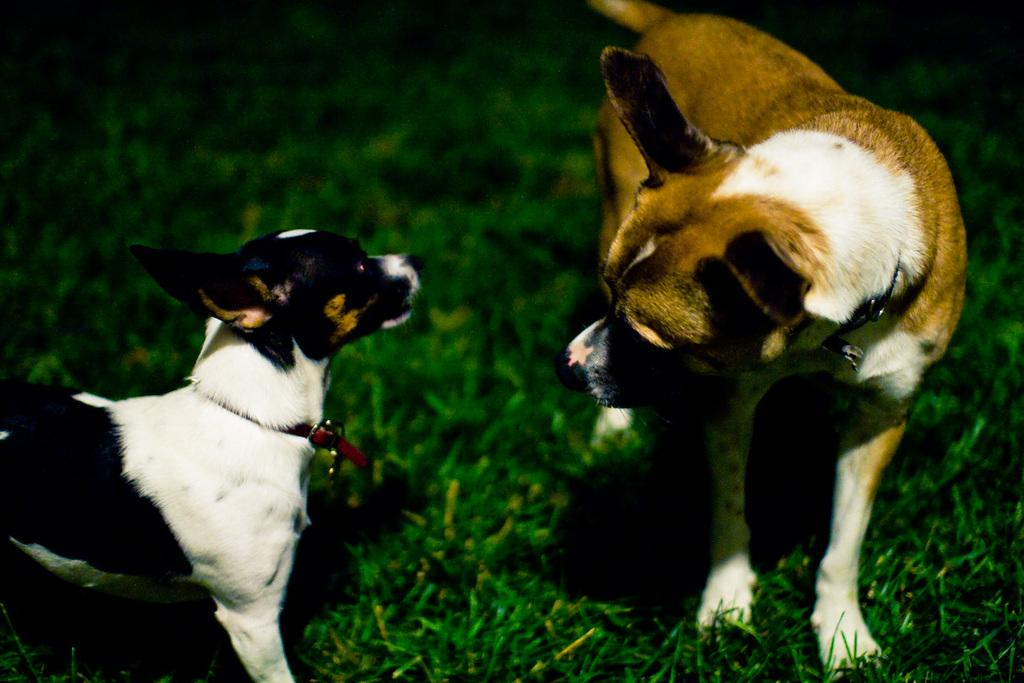How many dogs are present in the image? There are two dogs in the image. What are the dogs wearing around their necks? The dogs are wearing neck belts. Where are the dogs located in the image? The dogs are on the ground. Reasoning: Let's think step by breaking down the facts step by step to create the conversation. We start by identifying the main subject, which is the two dogs. Then, we describe what they are wearing, which are neck belts. Finally, we mention their location, which is on the ground. Each question is designed to provide specific details about the image based on the given facts. Absurd Question/Answer: What type of quill can be seen in the image? There is no quill present in the image; it features two dogs wearing neck belts and being on the ground. 